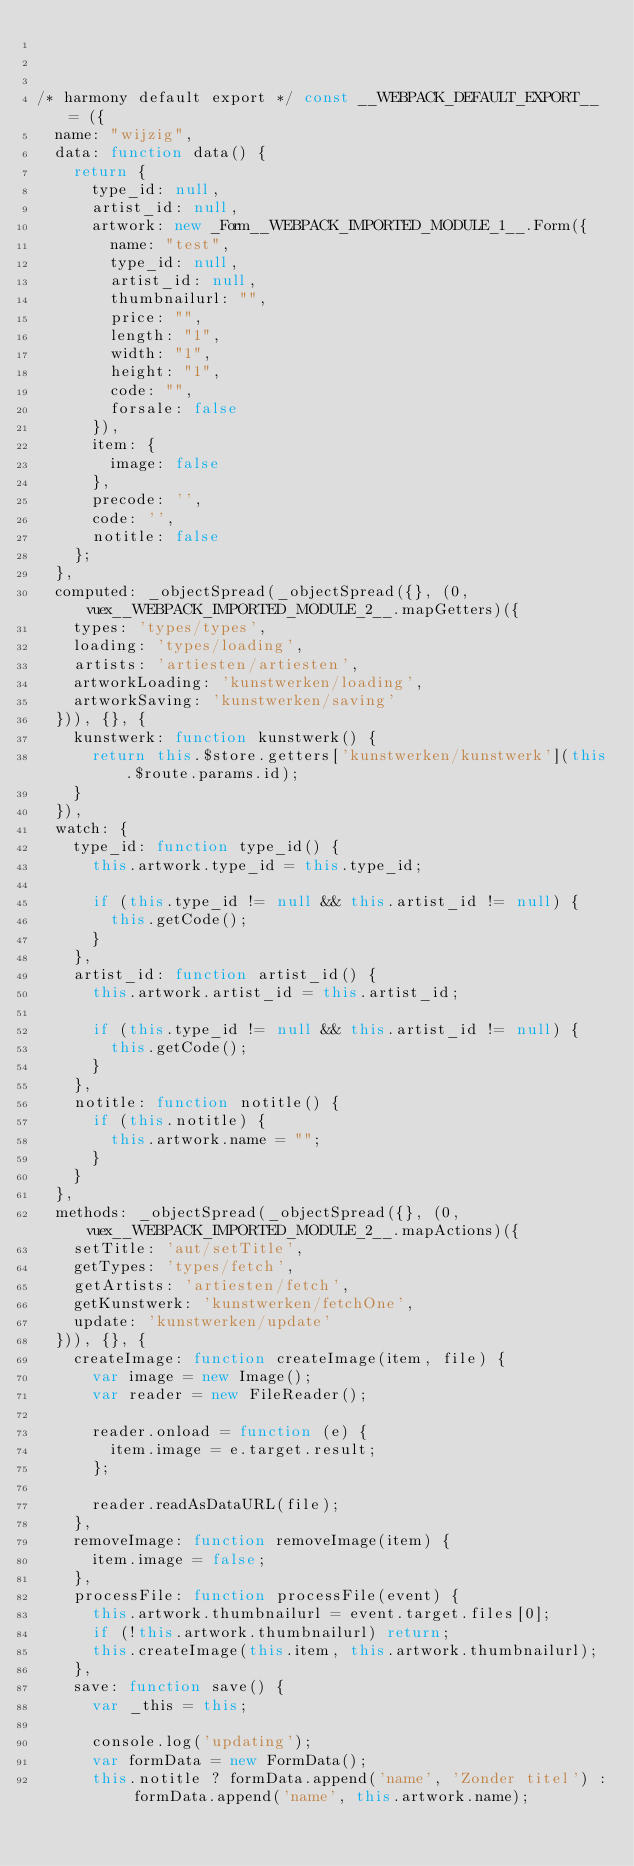Convert code to text. <code><loc_0><loc_0><loc_500><loc_500><_JavaScript_>


/* harmony default export */ const __WEBPACK_DEFAULT_EXPORT__ = ({
  name: "wijzig",
  data: function data() {
    return {
      type_id: null,
      artist_id: null,
      artwork: new _Form__WEBPACK_IMPORTED_MODULE_1__.Form({
        name: "test",
        type_id: null,
        artist_id: null,
        thumbnailurl: "",
        price: "",
        length: "1",
        width: "1",
        height: "1",
        code: "",
        forsale: false
      }),
      item: {
        image: false
      },
      precode: '',
      code: '',
      notitle: false
    };
  },
  computed: _objectSpread(_objectSpread({}, (0,vuex__WEBPACK_IMPORTED_MODULE_2__.mapGetters)({
    types: 'types/types',
    loading: 'types/loading',
    artists: 'artiesten/artiesten',
    artworkLoading: 'kunstwerken/loading',
    artworkSaving: 'kunstwerken/saving'
  })), {}, {
    kunstwerk: function kunstwerk() {
      return this.$store.getters['kunstwerken/kunstwerk'](this.$route.params.id);
    }
  }),
  watch: {
    type_id: function type_id() {
      this.artwork.type_id = this.type_id;

      if (this.type_id != null && this.artist_id != null) {
        this.getCode();
      }
    },
    artist_id: function artist_id() {
      this.artwork.artist_id = this.artist_id;

      if (this.type_id != null && this.artist_id != null) {
        this.getCode();
      }
    },
    notitle: function notitle() {
      if (this.notitle) {
        this.artwork.name = "";
      }
    }
  },
  methods: _objectSpread(_objectSpread({}, (0,vuex__WEBPACK_IMPORTED_MODULE_2__.mapActions)({
    setTitle: 'aut/setTitle',
    getTypes: 'types/fetch',
    getArtists: 'artiesten/fetch',
    getKunstwerk: 'kunstwerken/fetchOne',
    update: 'kunstwerken/update'
  })), {}, {
    createImage: function createImage(item, file) {
      var image = new Image();
      var reader = new FileReader();

      reader.onload = function (e) {
        item.image = e.target.result;
      };

      reader.readAsDataURL(file);
    },
    removeImage: function removeImage(item) {
      item.image = false;
    },
    processFile: function processFile(event) {
      this.artwork.thumbnailurl = event.target.files[0];
      if (!this.artwork.thumbnailurl) return;
      this.createImage(this.item, this.artwork.thumbnailurl);
    },
    save: function save() {
      var _this = this;

      console.log('updating');
      var formData = new FormData();
      this.notitle ? formData.append('name', 'Zonder titel') : formData.append('name', this.artwork.name);</code> 